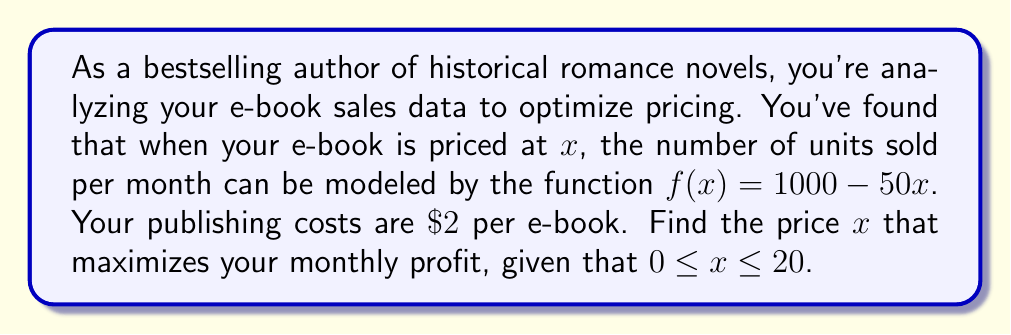Help me with this question. Let's approach this step-by-step:

1) First, we need to create a profit function. Profit is revenue minus costs.

2) Revenue is price times quantity: $x \cdot f(x) = x(1000 - 50x)$

3) Cost is $\$2$ per book times quantity: $2f(x) = 2(1000 - 50x)$

4) So, our profit function $P(x)$ is:
   $$P(x) = x(1000 - 50x) - 2(1000 - 50x)$$

5) Simplify:
   $$P(x) = 1000x - 50x^2 - 2000 + 100x$$
   $$P(x) = 1100x - 50x^2 - 2000$$

6) To find the maximum, we differentiate and set to zero:
   $$P'(x) = 1100 - 100x$$
   $$0 = 1100 - 100x$$
   $$100x = 1100$$
   $$x = 11$$

7) To confirm this is a maximum, check the second derivative:
   $$P''(x) = -100$$ which is negative, confirming a maximum.

8) We also need to check the endpoints of our interval $[0, 20]$:
   $P(0) = -2000$
   $P(20) = 22000 - 20000 - 2000 = 0$

9) $P(11) = 1100(11) - 50(11^2) - 2000 = 12100 - 6050 - 2000 = 4050$

Therefore, the maximum occurs at $x = 11$, within our interval.
Answer: The optimal price to maximize monthly profit is $\$11$ per e-book. 